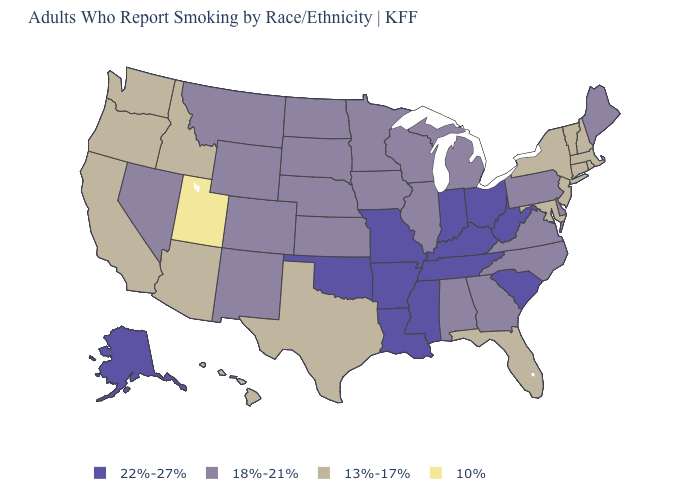What is the value of Nebraska?
Keep it brief. 18%-21%. Does Arizona have the same value as California?
Be succinct. Yes. What is the value of Hawaii?
Quick response, please. 13%-17%. Among the states that border New York , does Pennsylvania have the lowest value?
Quick response, please. No. Among the states that border Mississippi , does Alabama have the highest value?
Concise answer only. No. What is the value of Iowa?
Quick response, please. 18%-21%. Name the states that have a value in the range 18%-21%?
Answer briefly. Alabama, Colorado, Delaware, Georgia, Illinois, Iowa, Kansas, Maine, Michigan, Minnesota, Montana, Nebraska, Nevada, New Mexico, North Carolina, North Dakota, Pennsylvania, South Dakota, Virginia, Wisconsin, Wyoming. Does Indiana have the highest value in the MidWest?
Concise answer only. Yes. Name the states that have a value in the range 10%?
Keep it brief. Utah. Among the states that border Louisiana , which have the lowest value?
Be succinct. Texas. Name the states that have a value in the range 13%-17%?
Give a very brief answer. Arizona, California, Connecticut, Florida, Hawaii, Idaho, Maryland, Massachusetts, New Hampshire, New Jersey, New York, Oregon, Rhode Island, Texas, Vermont, Washington. Which states have the lowest value in the South?
Write a very short answer. Florida, Maryland, Texas. Name the states that have a value in the range 10%?
Give a very brief answer. Utah. What is the value of Michigan?
Concise answer only. 18%-21%. Does Vermont have the lowest value in the Northeast?
Short answer required. Yes. 